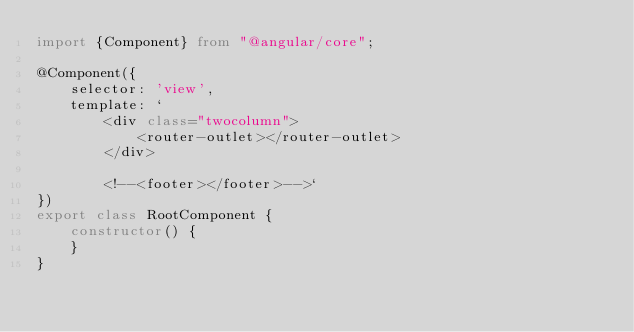<code> <loc_0><loc_0><loc_500><loc_500><_TypeScript_>import {Component} from "@angular/core";

@Component({
    selector: 'view',
    template: `
        <div class="twocolumn">
            <router-outlet></router-outlet>
        </div>

        <!--<footer></footer>-->`
})
export class RootComponent {
    constructor() {
    }
}
</code> 